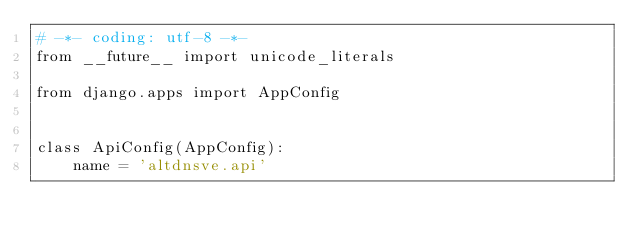<code> <loc_0><loc_0><loc_500><loc_500><_Python_># -*- coding: utf-8 -*-
from __future__ import unicode_literals

from django.apps import AppConfig


class ApiConfig(AppConfig):
    name = 'altdnsve.api'
</code> 